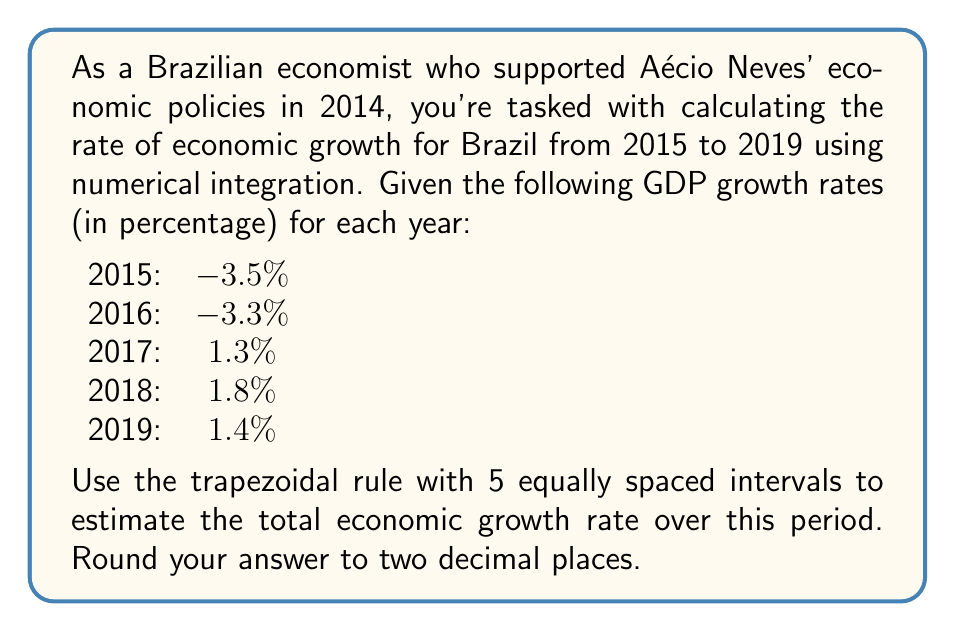Provide a solution to this math problem. To solve this problem, we'll use the trapezoidal rule for numerical integration. The steps are as follows:

1) The trapezoidal rule for n intervals is given by:

   $$\int_{a}^{b} f(x) dx \approx \frac{h}{2}[f(x_0) + 2f(x_1) + 2f(x_2) + ... + 2f(x_{n-1}) + f(x_n)]$$

   where $h = \frac{b-a}{n}$, and $x_i = a + ih$ for $i = 0, 1, ..., n$

2) In our case:
   $a = 2015$, $b = 2019$, $n = 5$
   $h = \frac{2019 - 2015}{5} = 0.8$ years

3) The function values are:
   $f(x_0) = -3.5$, $f(x_1) = -3.3$, $f(x_2) = 1.3$, $f(x_3) = 1.8$, $f(x_4) = 1.4$

4) Applying the trapezoidal rule:

   $$\text{Growth} \approx \frac{0.8}{2}[-3.5 + 2(-3.3) + 2(1.3) + 2(1.8) + 1.4]$$

5) Simplifying:

   $$\text{Growth} \approx 0.4[-3.5 - 6.6 + 2.6 + 3.6 + 1.4]$$
   $$\text{Growth} \approx 0.4[-2.5]$$
   $$\text{Growth} \approx -1.0$$

6) Therefore, the estimated total economic growth rate from 2015 to 2019 is -1.00%.
Answer: -1.00% 